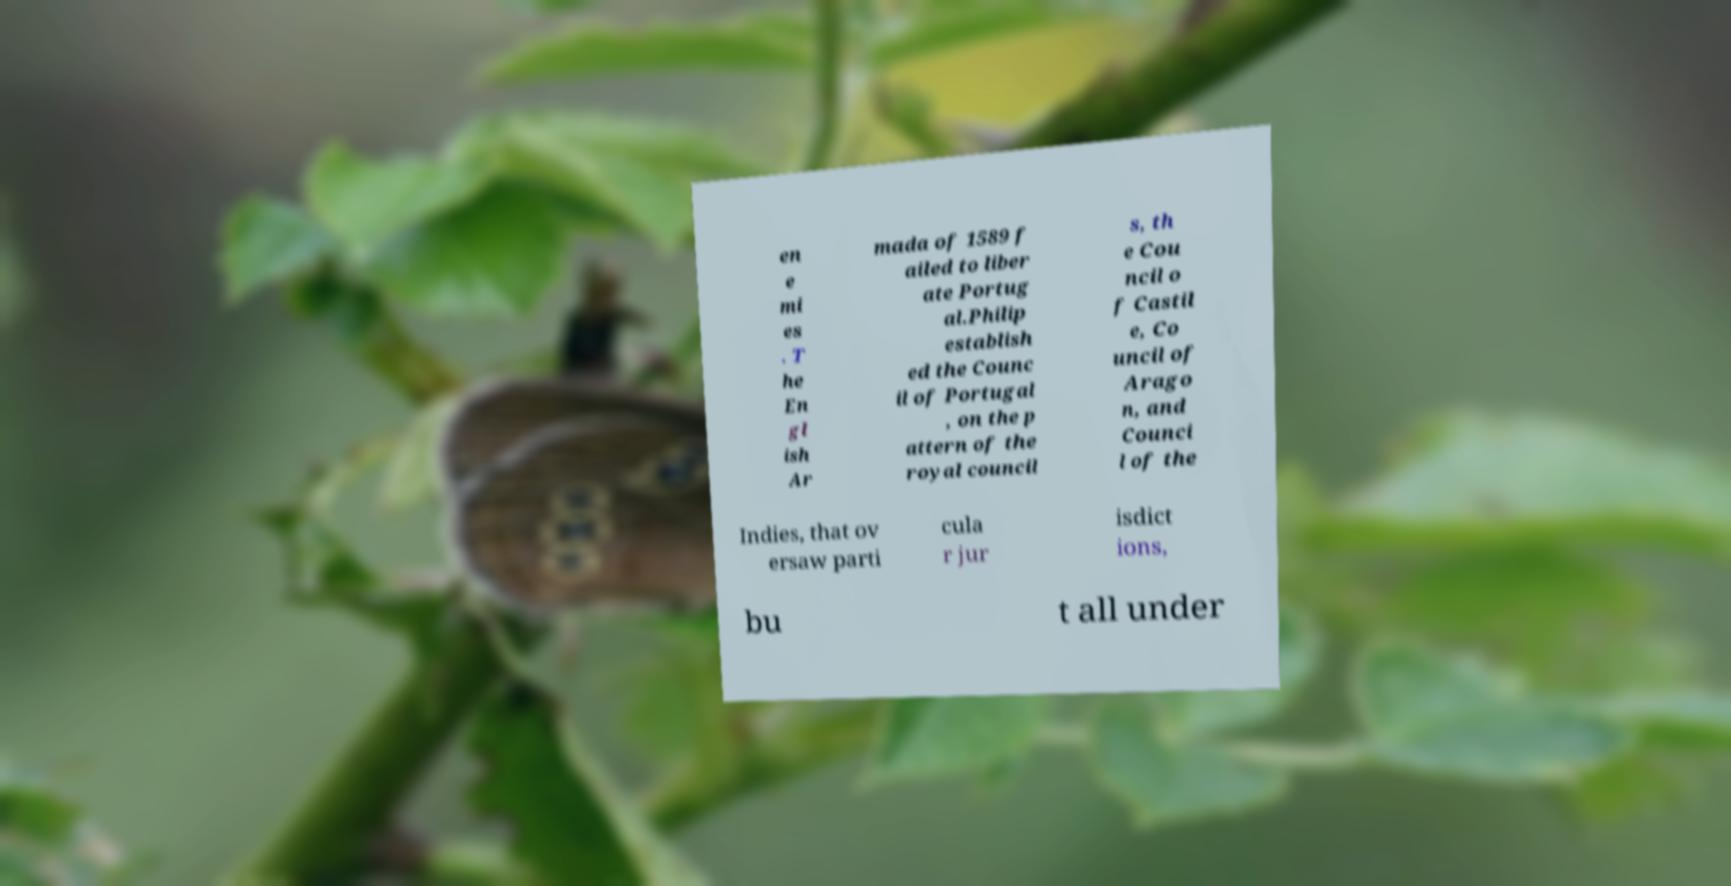Please read and relay the text visible in this image. What does it say? en e mi es . T he En gl ish Ar mada of 1589 f ailed to liber ate Portug al.Philip establish ed the Counc il of Portugal , on the p attern of the royal council s, th e Cou ncil o f Castil e, Co uncil of Arago n, and Counci l of the Indies, that ov ersaw parti cula r jur isdict ions, bu t all under 